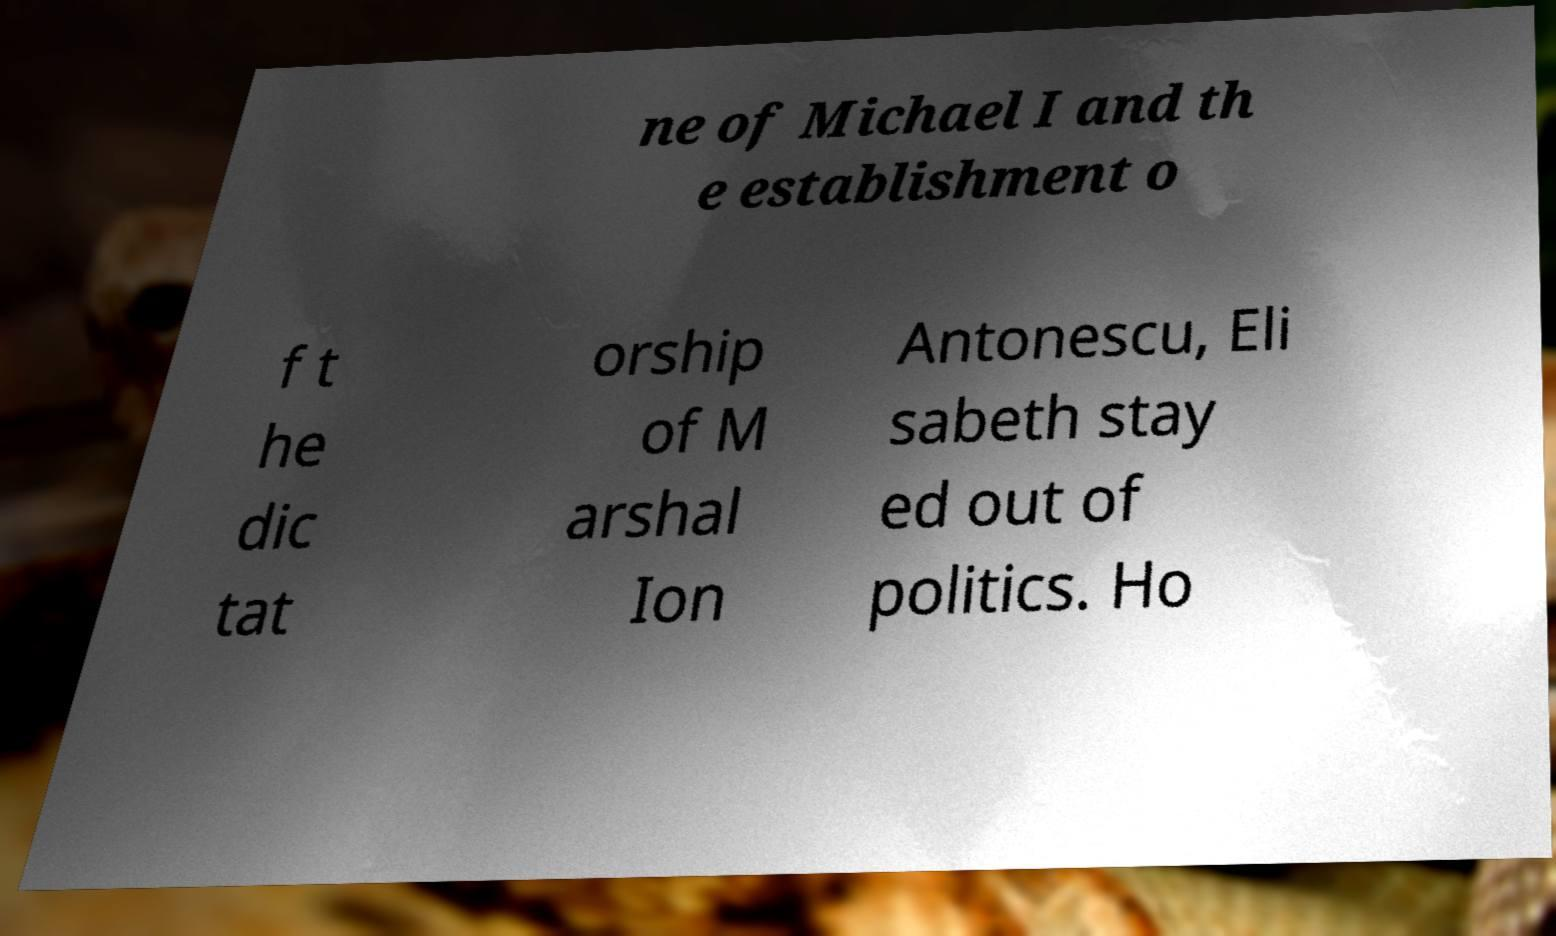Could you assist in decoding the text presented in this image and type it out clearly? ne of Michael I and th e establishment o f t he dic tat orship of M arshal Ion Antonescu, Eli sabeth stay ed out of politics. Ho 